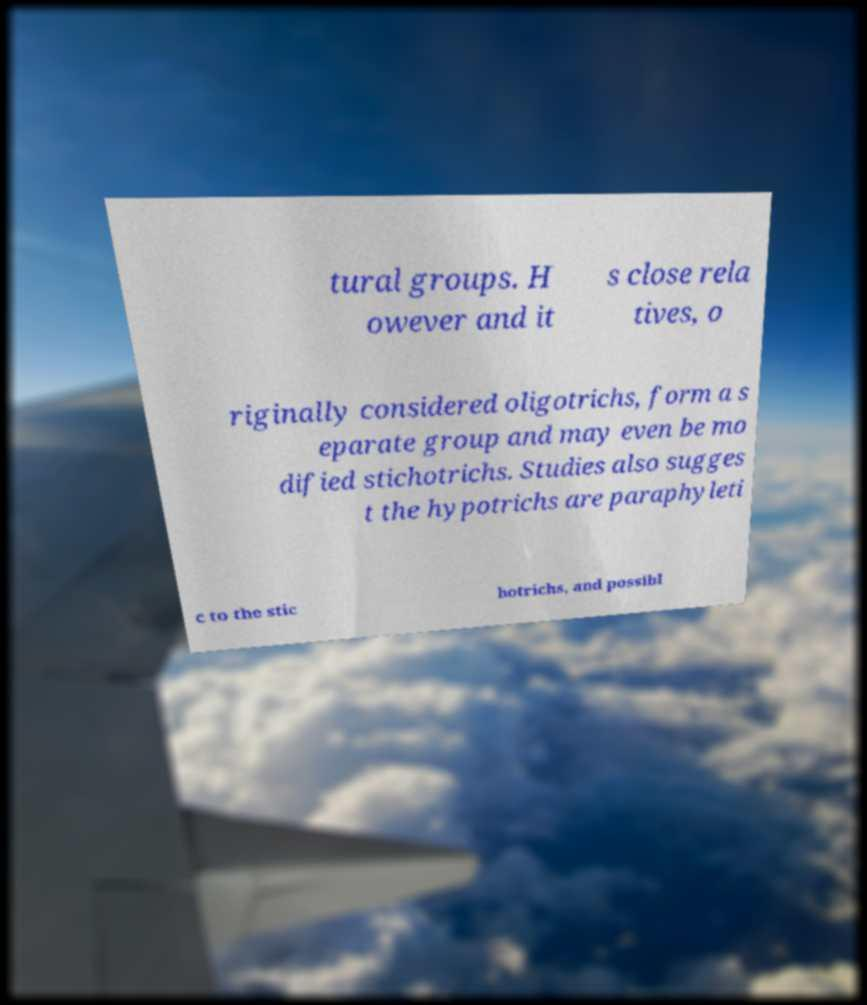Could you extract and type out the text from this image? tural groups. H owever and it s close rela tives, o riginally considered oligotrichs, form a s eparate group and may even be mo dified stichotrichs. Studies also sugges t the hypotrichs are paraphyleti c to the stic hotrichs, and possibl 